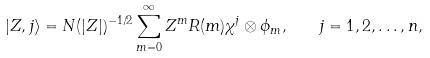Convert formula to latex. <formula><loc_0><loc_0><loc_500><loc_500>| Z , j \rangle = N ( | Z | ) ^ { - 1 / 2 } \sum _ { m = 0 } ^ { \infty } Z ^ { m } R ( m ) \chi ^ { j } \otimes \phi _ { m } , \quad j = 1 , 2 , \dots , n ,</formula> 